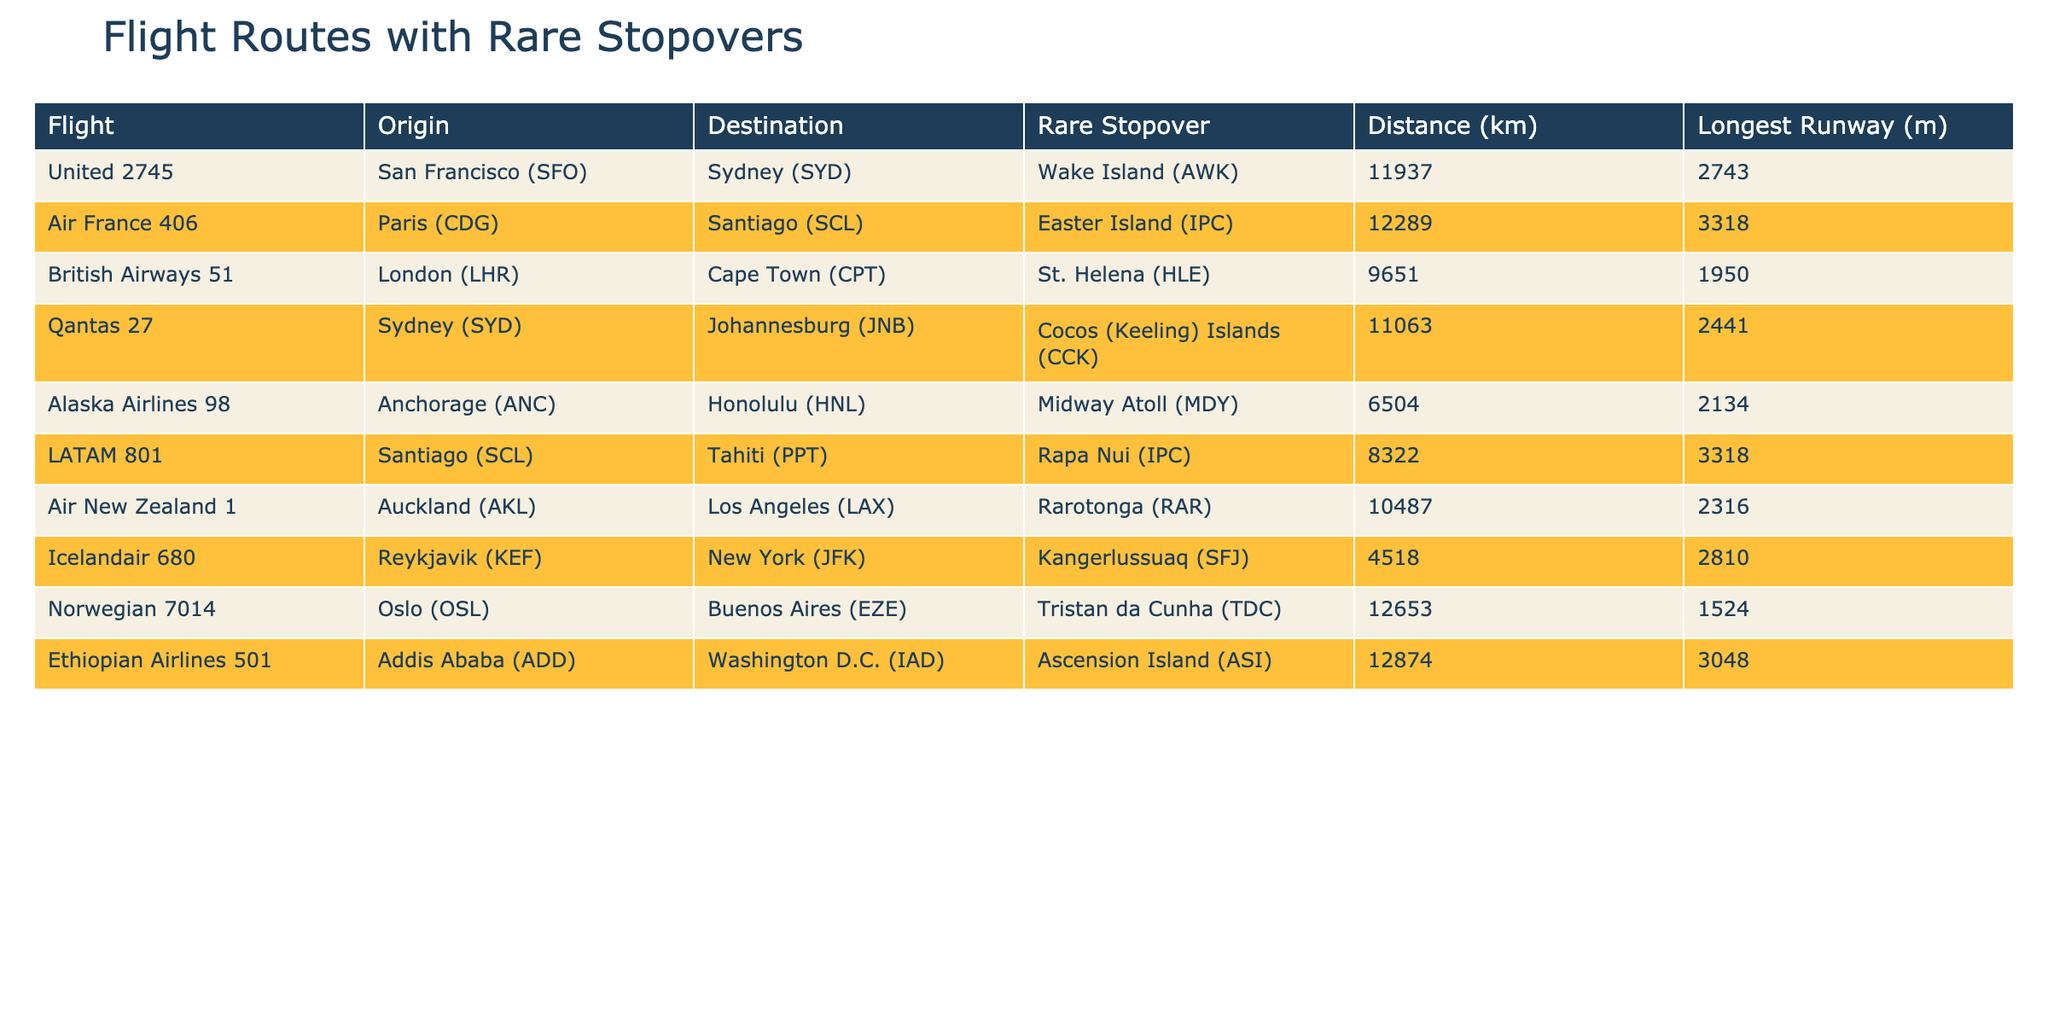What is the longest flight distance listed in the table? The table shows flight distances for various routes, and the longest distance can be found by comparing each distance value. The longest distance from the data is 12874 km, which is for the Ethiopian Airlines flight from Addis Ababa to Washington D.C.
Answer: 12874 km Which flight route has a rare stopover at St. Helena? By looking through the table, I can identify the specific flight that includes St. Helena as a rare stopover. It is British Airways flight 51 from London to Cape Town.
Answer: British Airways 51 What is the average distance of all the flights listed? To find the average distance, I sum all the distances (11937 + 12289 + 9651 + 11063 + 6504 + 8322 + 10487 + 4518 + 12653 + 12874) which totals to 112151 km. There are 10 flight routes, so the average distance is 112151/10 = 11215.1 km.
Answer: 11215.1 km Is there any flight that has a rare stopover longer than 3000 meters? By checking the longest runway for each flight listed in the table, I see which flights have a runway greater than 3000 meters. Ethiopian Airlines' flight has a runway of 3048 meters, which confirms that there is at least one such flight.
Answer: Yes Which flight has the shortest distance and what is it? To determine the shortest flight distance, I review the distances shown in the table and identify the lowest value. The shortest distance listed is 4518 km for the Icelandair flight from Reykjavik to New York.
Answer: Icelandair 680, 4518 km What is the difference in distance between the longest and shortest flight? To find the difference, I first identify the longest distance (12874 km by Ethiopian Airlines) and the shortest distance (4518 km by Icelandair). The difference is calculated as 12874 - 4518 = 8356 km.
Answer: 8356 km Which origin airport is used for the flight to Rarotonga? I look for the flight that lists Rarotonga (RAR) as a rare stopover and check its origin. The Air New Zealand flight from Auckland (AKL) goes to Los Angeles (LAX) with Rarotonga as a stopover.
Answer: Auckland (AKL) How many flights stop over at islands? I analyze the table and see which rare stopovers are associated with islands. The flights to Wake Island, Easter Island, Cocos (Keeling) Islands, Midway Atoll, Rapa Nui, and Rarotonga count as stopovers at islands, giving a total of 6 flights.
Answer: 6 flights Which airline has the longest runway for its rare stopover airport? I compare the longest runway values listed for each rare stopover. The longest runway is 3318 meters, which appears in the table for Air France and LATAM flights.
Answer: Air France and LATAM What is the unique feature of the flight to Tristan da Cunha? This flight, operated by Norwegian, has a rare stopover at Tristan da Cunha, which is known as the most remote inhabited archipelago. Its inclusion in the table highlights the uniqueness of this route.
Answer: Rare stopover at Tristan da Cunha 